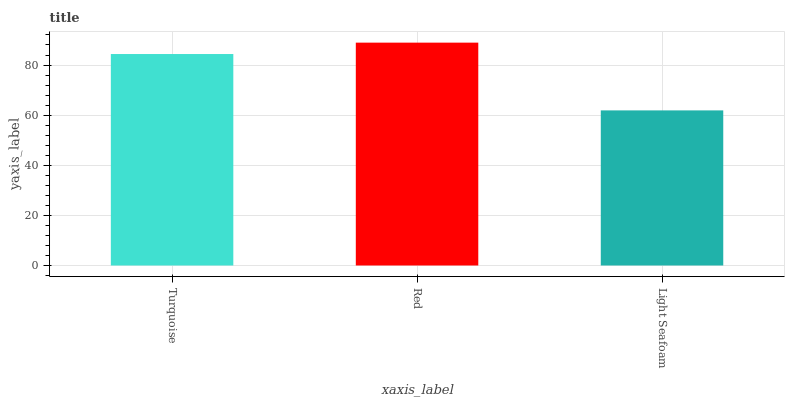Is Light Seafoam the minimum?
Answer yes or no. Yes. Is Red the maximum?
Answer yes or no. Yes. Is Red the minimum?
Answer yes or no. No. Is Light Seafoam the maximum?
Answer yes or no. No. Is Red greater than Light Seafoam?
Answer yes or no. Yes. Is Light Seafoam less than Red?
Answer yes or no. Yes. Is Light Seafoam greater than Red?
Answer yes or no. No. Is Red less than Light Seafoam?
Answer yes or no. No. Is Turquoise the high median?
Answer yes or no. Yes. Is Turquoise the low median?
Answer yes or no. Yes. Is Red the high median?
Answer yes or no. No. Is Light Seafoam the low median?
Answer yes or no. No. 